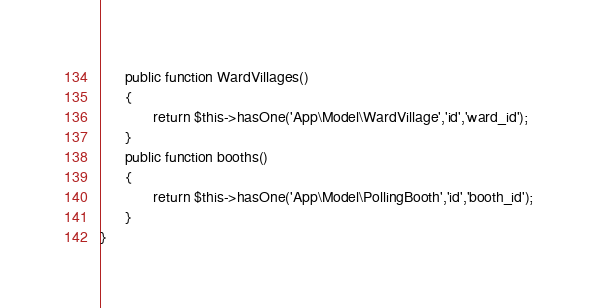Convert code to text. <code><loc_0><loc_0><loc_500><loc_500><_PHP_>      public function WardVillages()
      {
             return $this->hasOne('App\Model\WardVillage','id','ward_id');
      }
      public function booths()
      {
             return $this->hasOne('App\Model\PollingBooth','id','booth_id');
      }
}
</code> 